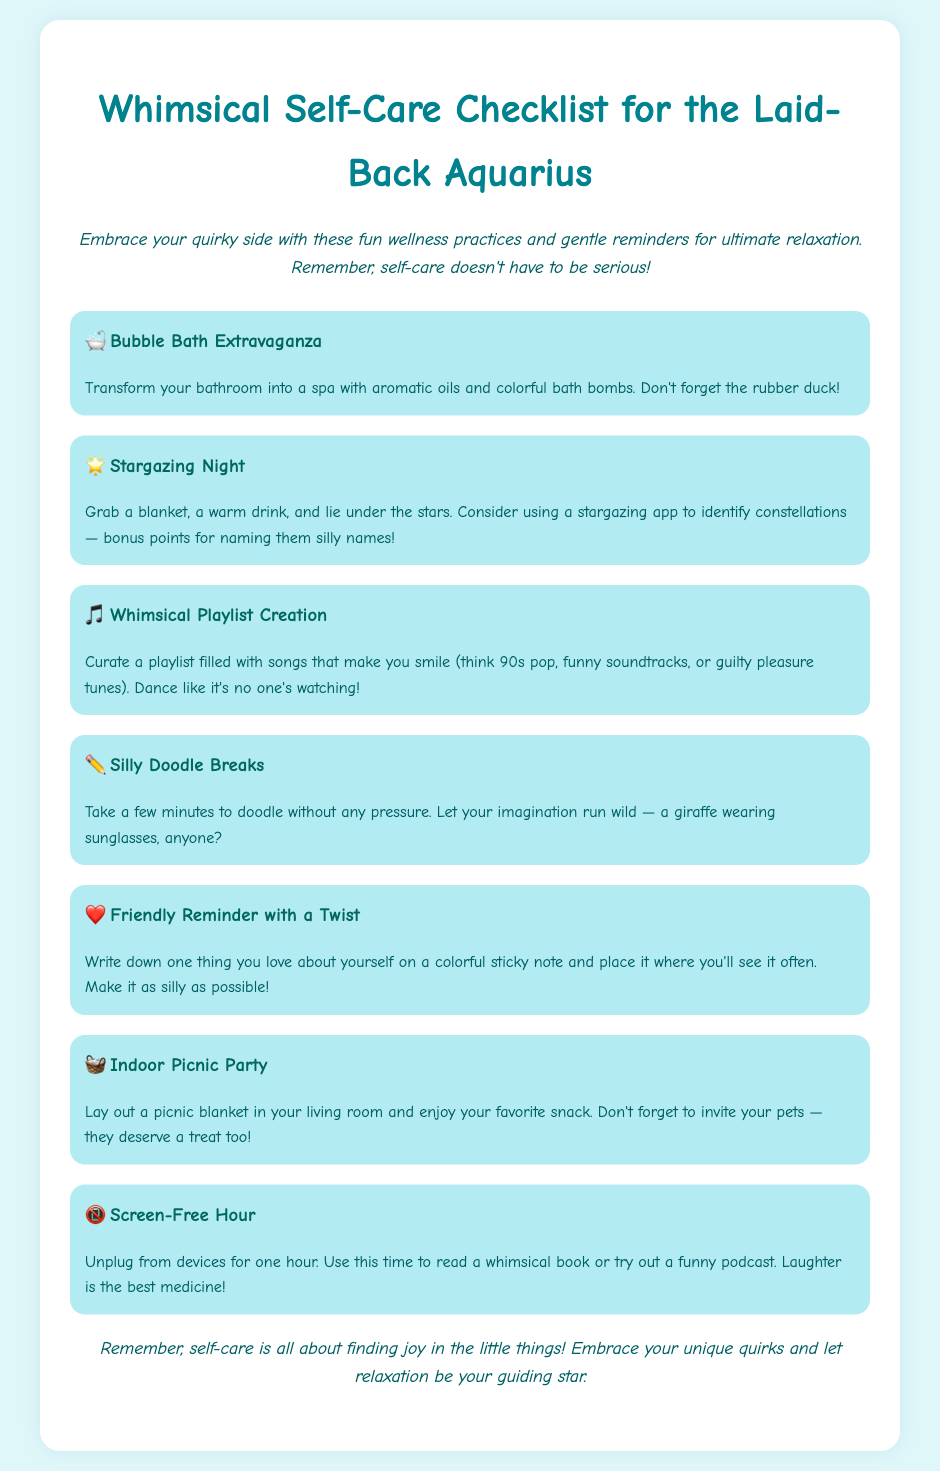what is the title of the document? The title is found in the header of the document.
Answer: Whimsical Self-Care Checklist for the Laid-Back Aquarius how many checklist items are there? The number of items can be counted from the list in the document.
Answer: 7 what is one suggested activity for self-care? The document lists various activities for self-care under each checklist item.
Answer: Bubble Bath Extravaganza which item suggests using a stargazing app? The item related to this activity is mentioned in the second checklist item.
Answer: Stargazing Night what should you do during the Indoor Picnic Party? This is outlined in the description under the corresponding checklist item.
Answer: Enjoy your favorite snack what type of music should be included in the whimsical playlist? The document specifies the kinds of songs to include in the playlist.
Answer: 90s pop what should you write on a sticky note? The document advises you to write something about yourself on a sticky note.
Answer: One thing you love about yourself which item encourages unplugging from devices? This item is explicitly mentioned in the checklist.
Answer: Screen-Free Hour 